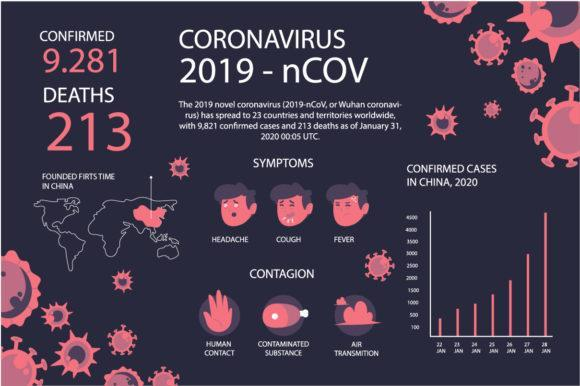When did the confirmed cases in China reach the maximum in 2020 according to the graph?
Answer the question with a short phrase. 28 JAN How does covid virus spread? HUMAN CONTACT, CONTAMINATED SUBSTANCE, AIR TRANSMITION What are the symptoms of coronavirus? HEADACHE, COUGH, FEVER 